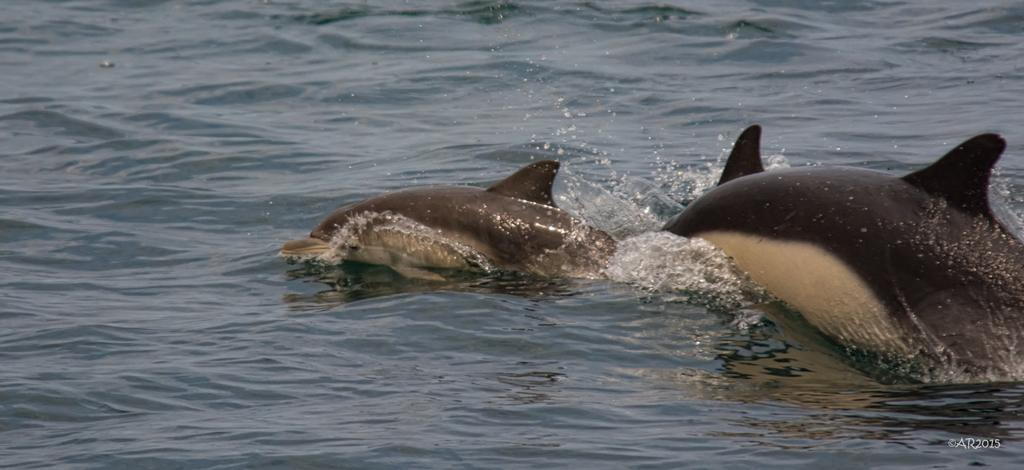How many dolphins are visible in the image? There are 2 dolphins in the water. Can you describe any other elements in the image besides the dolphins? There is a watermark in the bottom corner of the picture. What type of carriage can be seen in the image? There is no carriage present in the image; it features 2 dolphins in the water and a watermark in the bottom corner. What is the spark used for in the image? There is no spark present in the image. 